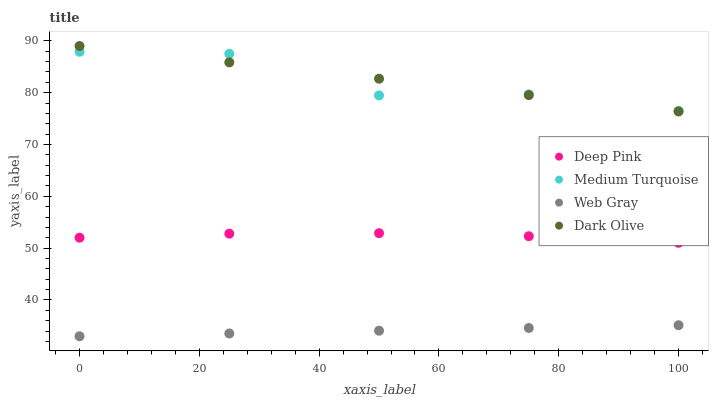Does Web Gray have the minimum area under the curve?
Answer yes or no. Yes. Does Dark Olive have the maximum area under the curve?
Answer yes or no. Yes. Does Deep Pink have the minimum area under the curve?
Answer yes or no. No. Does Deep Pink have the maximum area under the curve?
Answer yes or no. No. Is Web Gray the smoothest?
Answer yes or no. Yes. Is Medium Turquoise the roughest?
Answer yes or no. Yes. Is Deep Pink the smoothest?
Answer yes or no. No. Is Deep Pink the roughest?
Answer yes or no. No. Does Web Gray have the lowest value?
Answer yes or no. Yes. Does Deep Pink have the lowest value?
Answer yes or no. No. Does Dark Olive have the highest value?
Answer yes or no. Yes. Does Deep Pink have the highest value?
Answer yes or no. No. Is Web Gray less than Medium Turquoise?
Answer yes or no. Yes. Is Medium Turquoise greater than Web Gray?
Answer yes or no. Yes. Does Medium Turquoise intersect Dark Olive?
Answer yes or no. Yes. Is Medium Turquoise less than Dark Olive?
Answer yes or no. No. Is Medium Turquoise greater than Dark Olive?
Answer yes or no. No. Does Web Gray intersect Medium Turquoise?
Answer yes or no. No. 